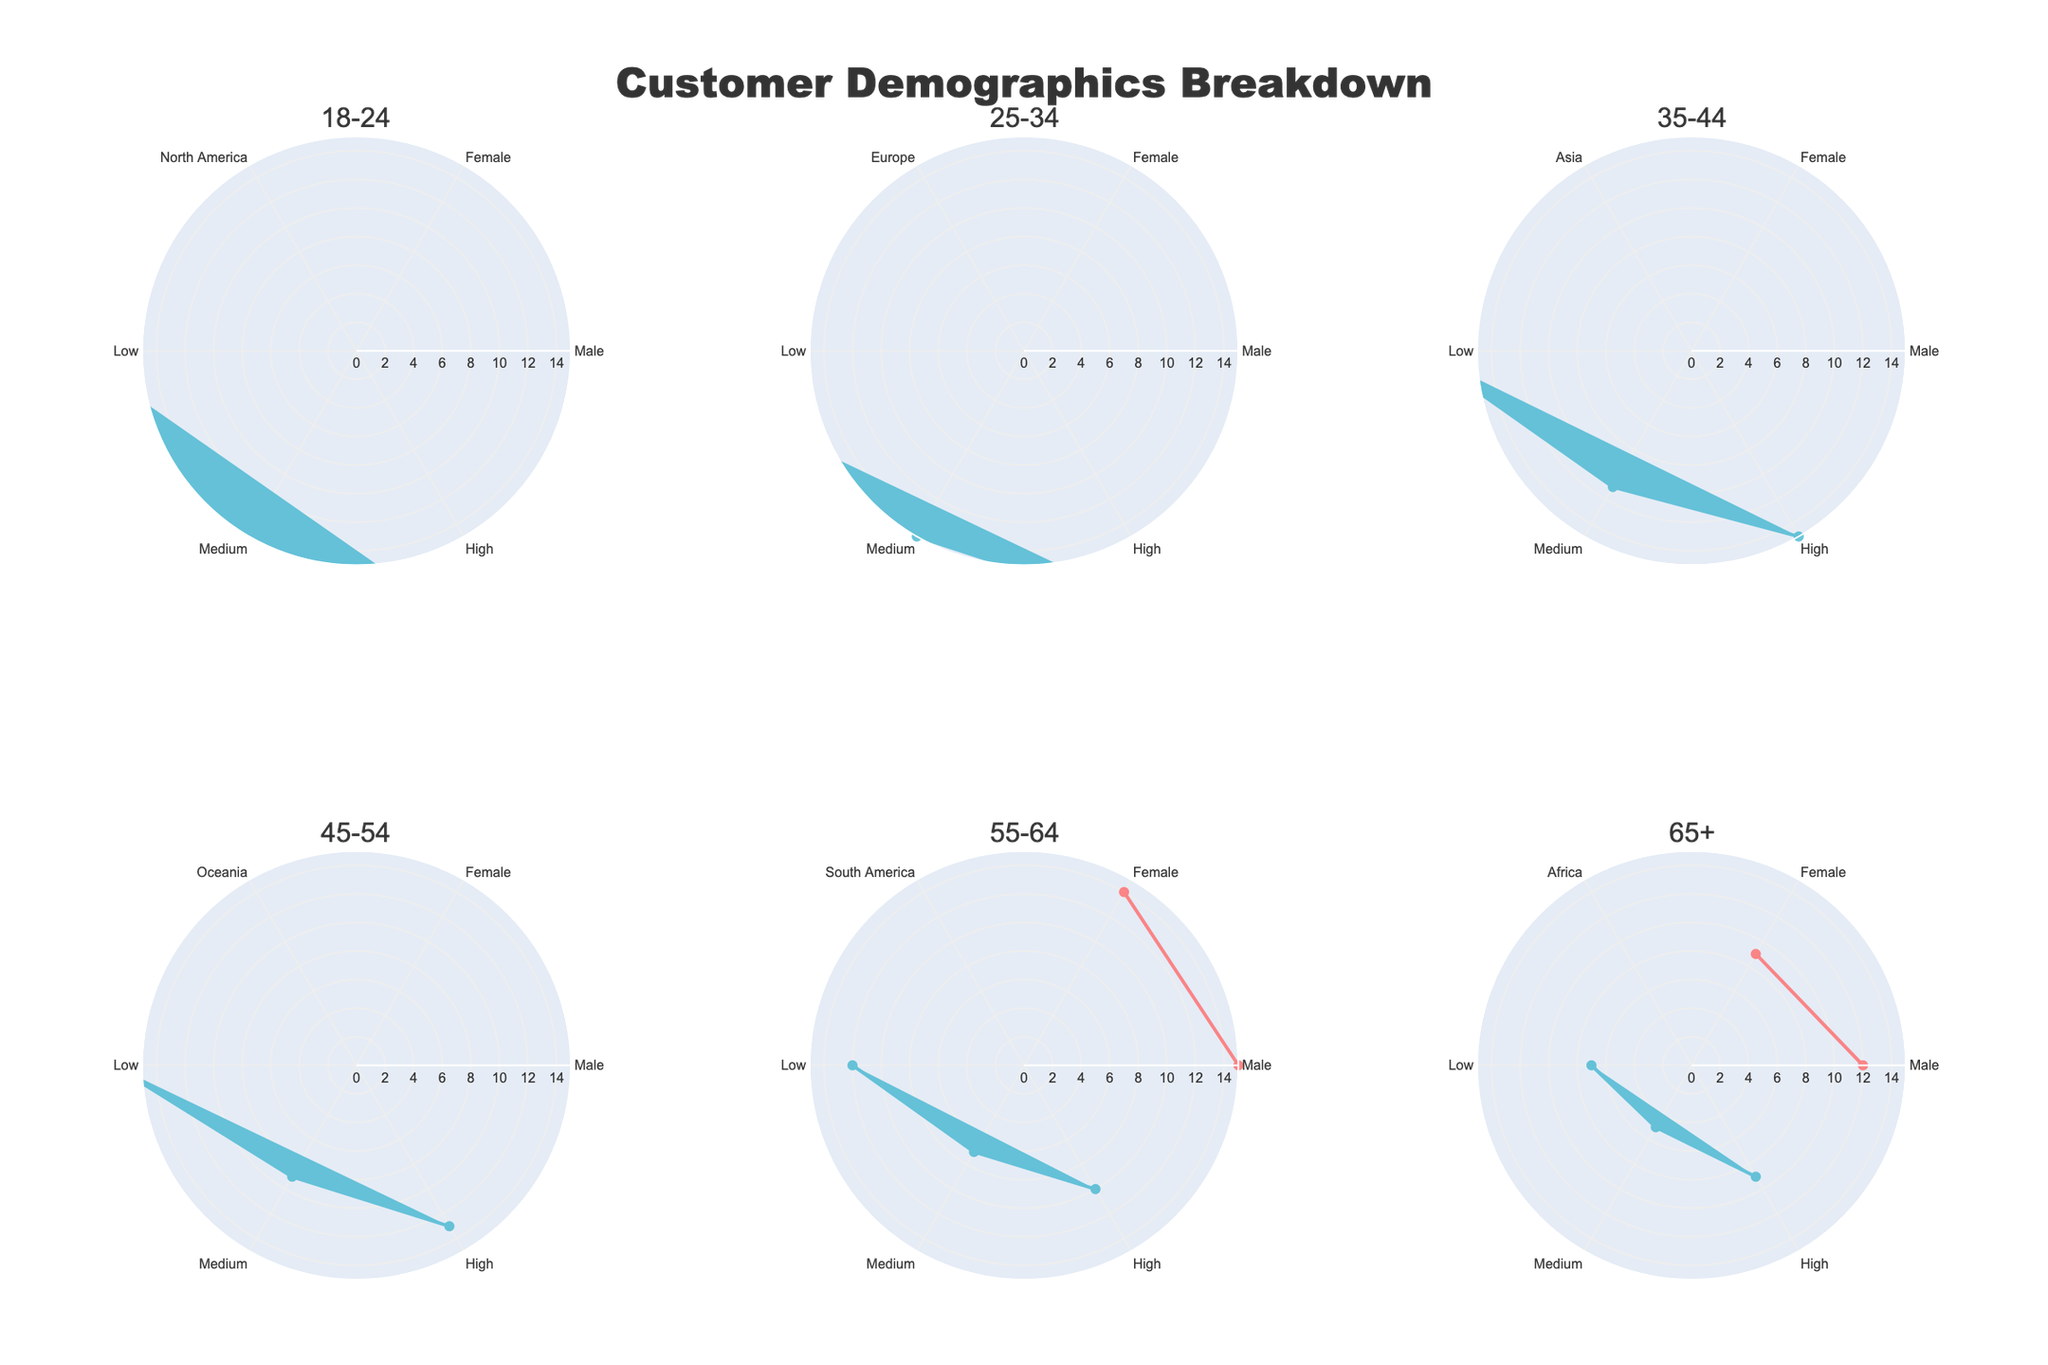Which age group exhibits the highest percentage of each income level in North America? In the subplot for the age group '18-24', the radar chart shows that the 'Medium' income level has the highest percentage for both genders combined, summing up to the highest values across all other income levels in North America.
Answer: 18-24 Which geographic location has the highest representation in the 25-34 age group? By observing the radar chart for the age group '25-34', the 'Europe' segment displays the highest combined percentages for both males and females across all three income levels (Low, Medium, High).
Answer: Europe For the age group 35-44 in Asia, how do the percentages of low and high-income levels compare? In the radar chart for '35-44' in 'Asia', the percentages for low-income levels are 5% (Male) and 6% (Female), while for high-income levels, they are 9% (Male) and 10% (Female). Clearly, the percentages for high-income levels are higher than those for low-income levels.
Answer: High-income levels are higher What is the common trend observed in the gender distribution across all age groups? Across all subplots, it can be observed that the percentages for males and females are closely aligned across the income levels for each age group. This indicates a balanced gender distribution.
Answer: Balanced gender distribution Which age group has the lowest combined percentage in the 'High' income level for their respective geographic location? By examining all subplots, the '65+' age group in 'Africa' shows the combined lowest percentages for the 'High' income level, with 3% (Male) and 4% (Female), totaling 7%.
Answer: 65+ Which category has the most consistent percentage distribution across all age groups? Observing all subplots, the 'Gender' category consistently shows nearly equal contributions from males and females across different income levels and geographic locations, illustrating a stable distribution.
Answer: Gender For the age group 45-54 in Oceania, which gender and income level combination has the highest percentage? Focusing on the age group '45-54' in 'Oceania', the radar chart reveals that the 'High' income level for 'Female' holds the highest percentage among the combinations.
Answer: Female, High 